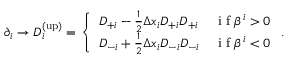<formula> <loc_0><loc_0><loc_500><loc_500>\begin{array} { r } { \partial _ { i } \rightarrow D _ { i } ^ { ( u p ) } = \left \{ \begin{array} { l l } { D _ { + i } - \frac { 1 } { 2 } \Delta x _ { i } D _ { + i } D _ { + i } } & { i f \beta ^ { i } > 0 } \\ { D _ { - i } + \frac { 1 } { 2 } \Delta x _ { i } D _ { - i } D _ { - i } } & { i f \beta ^ { i } < 0 } \end{array} . } \end{array}</formula> 